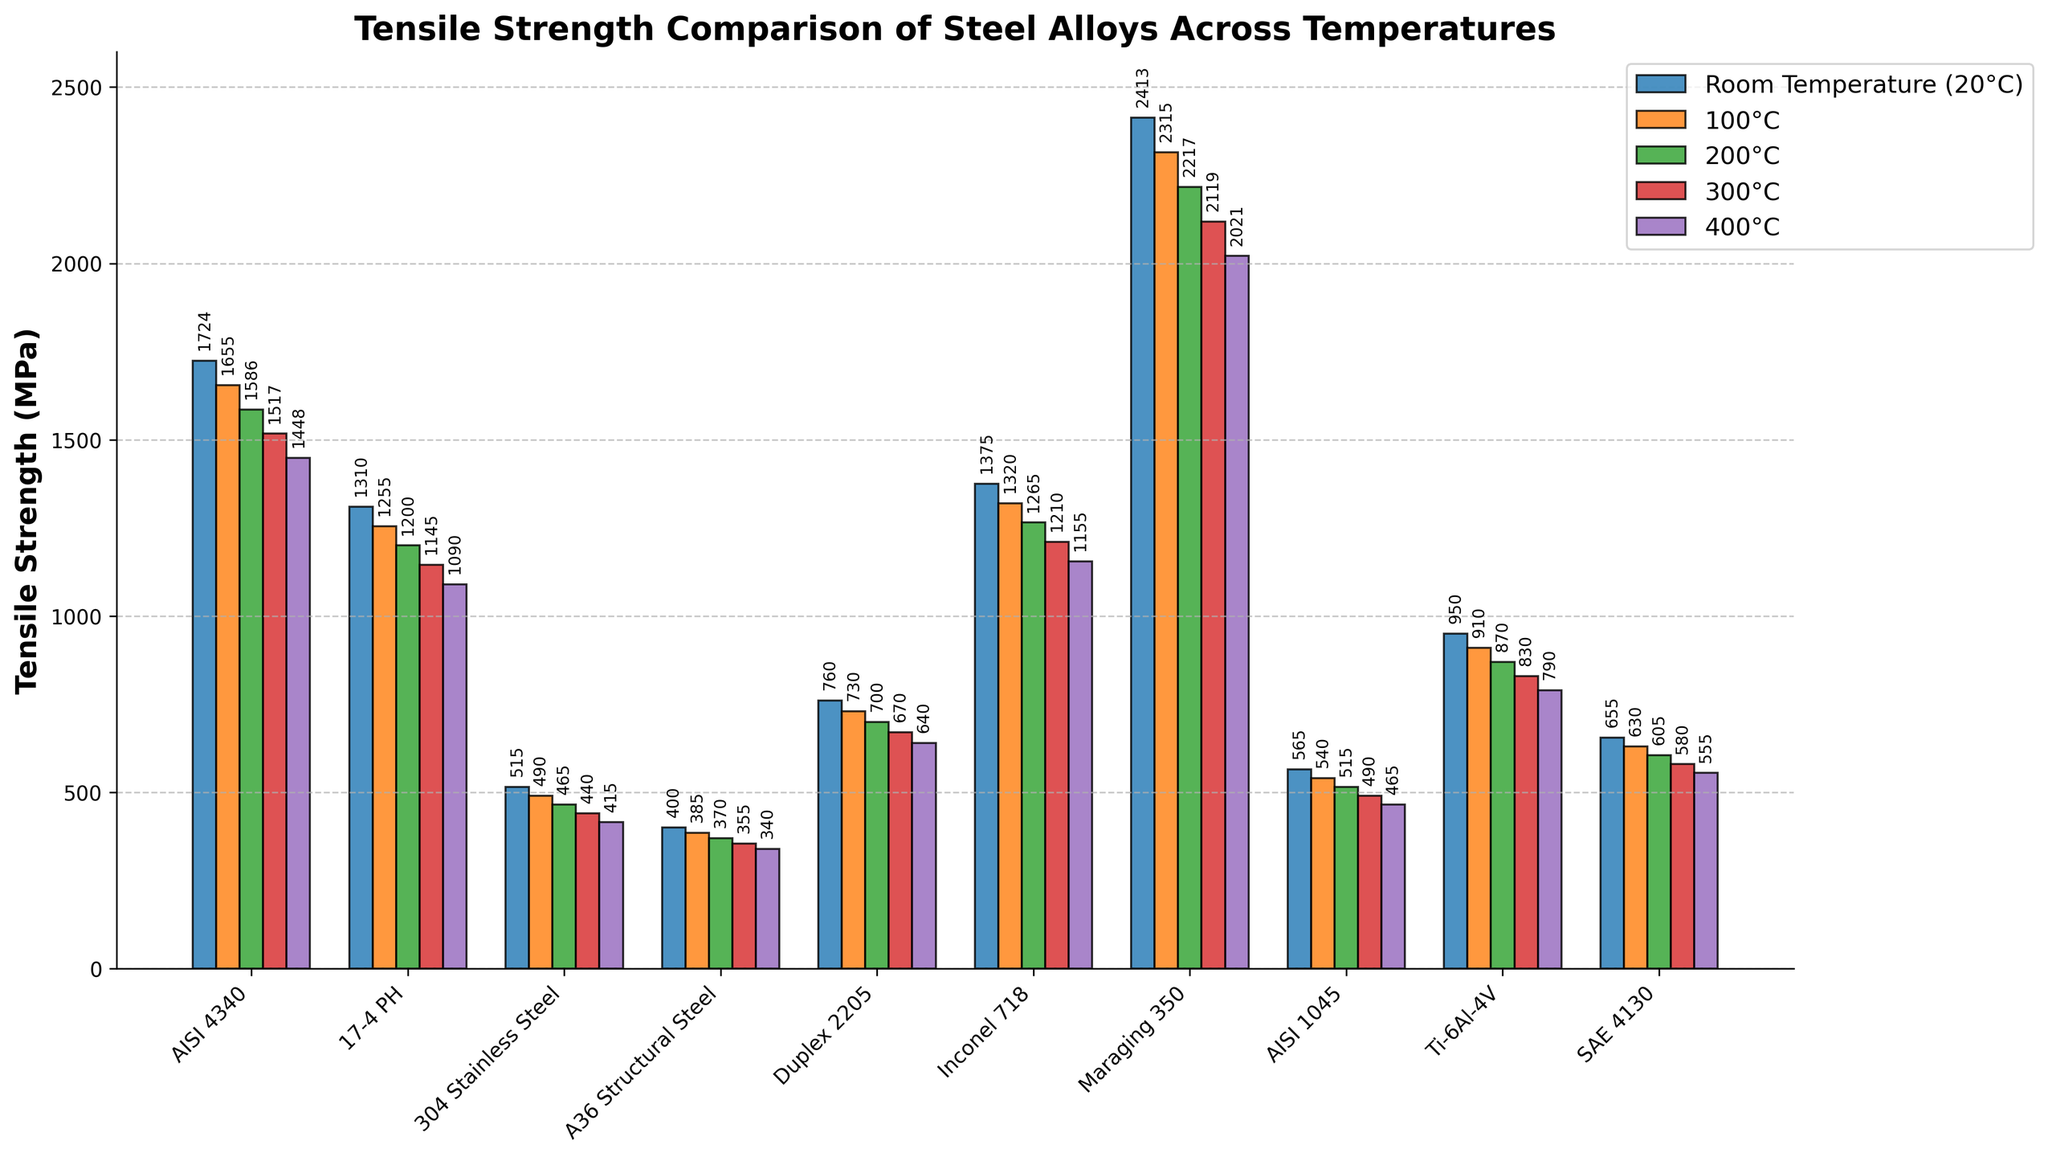What is the tensile strength of AISI 4340 at 300°C? Look at the bar corresponding to AISI 4340 and 300°C (the fourth bar set) to find its height value.
Answer: 1517 MPa Which alloy has the highest tensile strength at room temperature? Compare the heights of all bars in the first set (Room Temperature) across all alloys. The tallest bar represents the highest tensile strength. Maraging 350 is the highest.
Answer: Maraging 350 What is the difference in tensile strength between Inconel 718 and 17-4 PH at 200°C? Identify the heights of the bars for Inconel 718 and 17-4 PH in the third set (200°C) and subtract the value of 17-4 PH from Inconel 718.
Answer: 65 MPa Which temperature shows the smallest decline in tensile strength for AISI 1045 from room temperature to 400°C? Calculate the decline at each temperature (Room Temp - Temp Value) for AISI 1045 and identify the smallest decline. The values are (565-540), (565-515), (565-490), (565-465), with the smallest decline being from room temperature to 100°C.
Answer: 25 MPa At 100°C, what is the difference in tensile strength between the strongest and weakest alloy? Find the tensile strength values for all alloys at 100°C, identify the maximum and minimum values, and subtract the minimum from the maximum.
Answer: 1775 MPa How does the tensile strength of Duplex 2205 at 400°C compare with that of A36 Structural Steel at room temperature? Compare the heights of the bars for Duplex 2205 at 400°C and A36 Structural Steel at room temperature.
Answer: Higher for Duplex 2205 Calculate the average tensile strength of Ti-6Al-4V across all temperatures. Sum the tensile strength values of Ti-6Al-4V for all temperatures and divide by the number of temperature points (5). (950 + 910 + 870 + 830 + 790) / 5 = 870
Answer: 870 MPa Which alloy shows the steepest decline in tensile strength from room temperature to 400°C? Calculate the decline at each temperature (Room Temp - 400°C value) for all alloys and identify the largest value. The calculation for Maraging 350 shows the steepest decline.
Answer: Maraging 350 Is there any alloy that has a tensile strength below 500 MPa at any temperature? Scan the figure for any bar that is below the 500 MPa mark. Both 304 Stainless Steel and A36 Structural Steel have bars below 500 MPa at some temperatures.
Answer: Yes (304 Stainless Steel, A36 Structural Steel) 